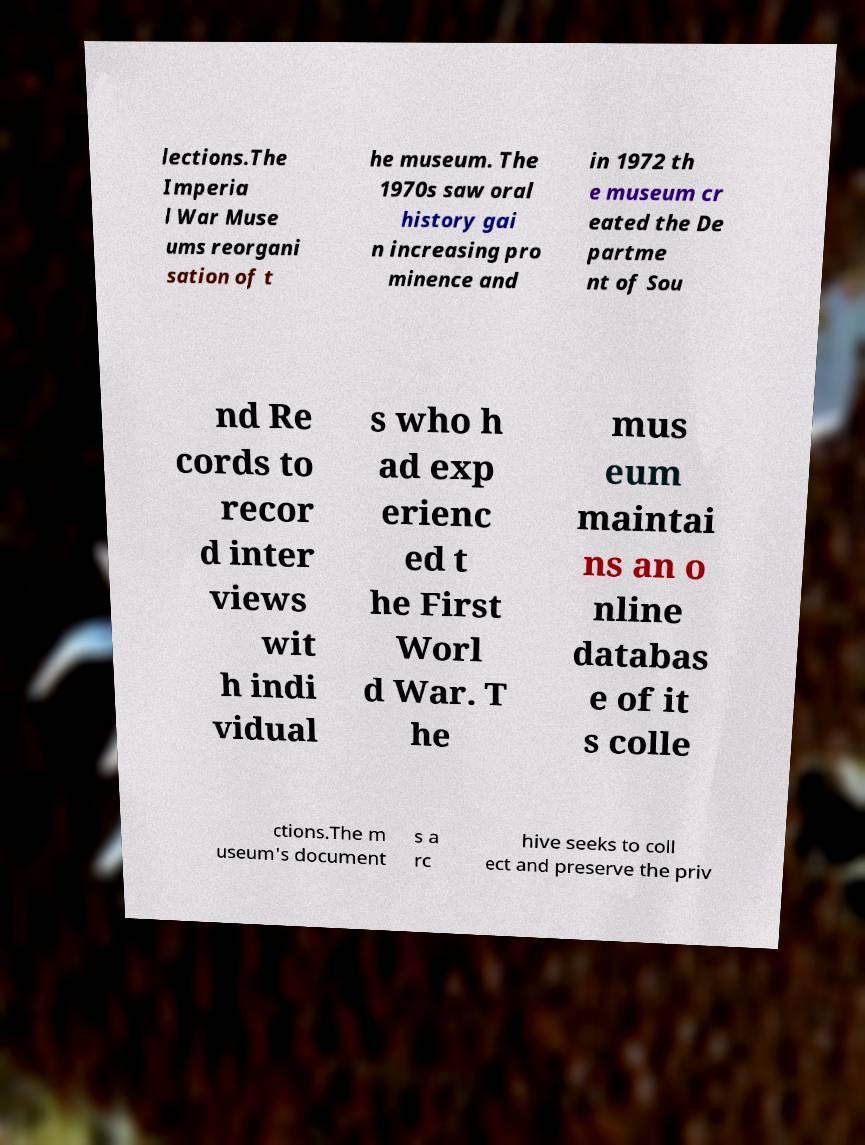Could you assist in decoding the text presented in this image and type it out clearly? lections.The Imperia l War Muse ums reorgani sation of t he museum. The 1970s saw oral history gai n increasing pro minence and in 1972 th e museum cr eated the De partme nt of Sou nd Re cords to recor d inter views wit h indi vidual s who h ad exp erienc ed t he First Worl d War. T he mus eum maintai ns an o nline databas e of it s colle ctions.The m useum's document s a rc hive seeks to coll ect and preserve the priv 